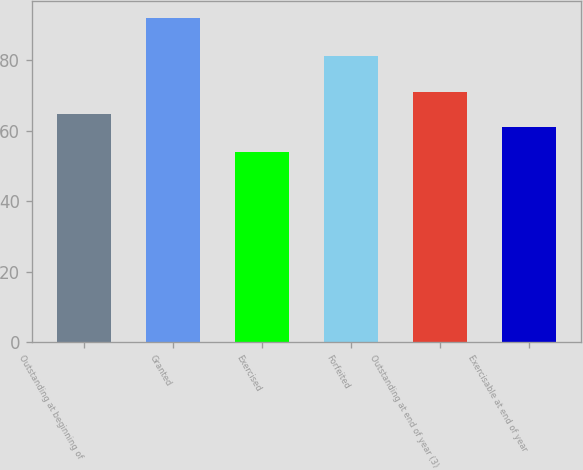<chart> <loc_0><loc_0><loc_500><loc_500><bar_chart><fcel>Outstanding at beginning of<fcel>Granted<fcel>Exercised<fcel>Forfeited<fcel>Outstanding at end of year (3)<fcel>Exercisable at end of year<nl><fcel>64.8<fcel>92<fcel>54<fcel>81<fcel>71<fcel>61<nl></chart> 